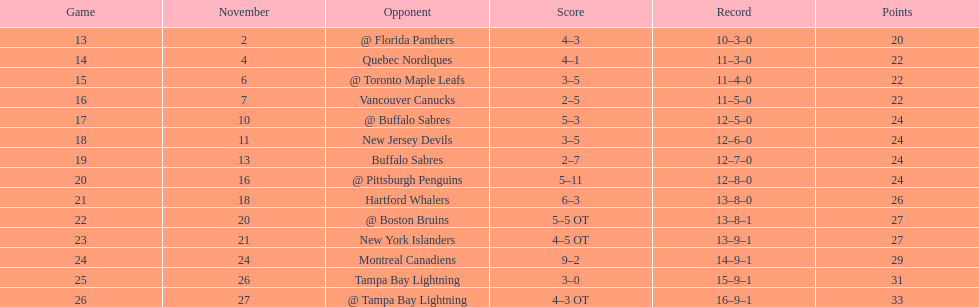Would you be able to parse every entry in this table? {'header': ['Game', 'November', 'Opponent', 'Score', 'Record', 'Points'], 'rows': [['13', '2', '@ Florida Panthers', '4–3', '10–3–0', '20'], ['14', '4', 'Quebec Nordiques', '4–1', '11–3–0', '22'], ['15', '6', '@ Toronto Maple Leafs', '3–5', '11–4–0', '22'], ['16', '7', 'Vancouver Canucks', '2–5', '11–5–0', '22'], ['17', '10', '@ Buffalo Sabres', '5–3', '12–5–0', '24'], ['18', '11', 'New Jersey Devils', '3–5', '12–6–0', '24'], ['19', '13', 'Buffalo Sabres', '2–7', '12–7–0', '24'], ['20', '16', '@ Pittsburgh Penguins', '5–11', '12–8–0', '24'], ['21', '18', 'Hartford Whalers', '6–3', '13–8–0', '26'], ['22', '20', '@ Boston Bruins', '5–5 OT', '13–8–1', '27'], ['23', '21', 'New York Islanders', '4–5 OT', '13–9–1', '27'], ['24', '24', 'Montreal Canadiens', '9–2', '14–9–1', '29'], ['25', '26', 'Tampa Bay Lightning', '3–0', '15–9–1', '31'], ['26', '27', '@ Tampa Bay Lightning', '4–3 OT', '16–9–1', '33']]} What other team had the closest amount of wins? New York Islanders. 